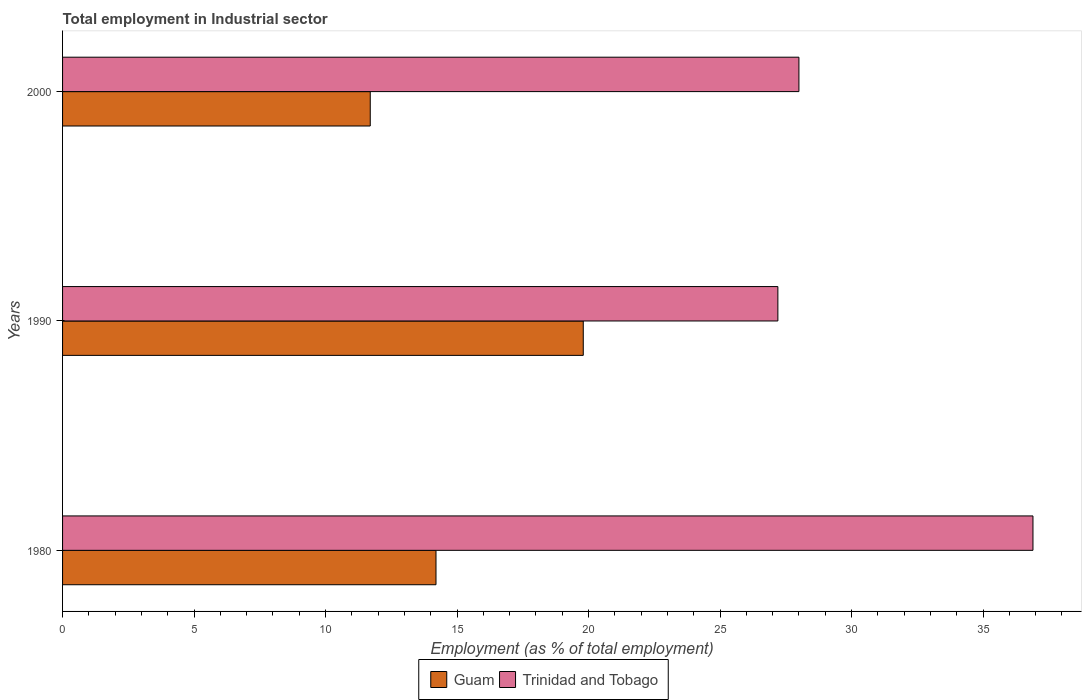How many different coloured bars are there?
Keep it short and to the point. 2. Are the number of bars on each tick of the Y-axis equal?
Offer a terse response. Yes. How many bars are there on the 3rd tick from the bottom?
Keep it short and to the point. 2. What is the label of the 2nd group of bars from the top?
Provide a short and direct response. 1990. In how many cases, is the number of bars for a given year not equal to the number of legend labels?
Make the answer very short. 0. What is the employment in industrial sector in Guam in 2000?
Provide a succinct answer. 11.7. Across all years, what is the maximum employment in industrial sector in Guam?
Give a very brief answer. 19.8. Across all years, what is the minimum employment in industrial sector in Trinidad and Tobago?
Provide a succinct answer. 27.2. In which year was the employment in industrial sector in Trinidad and Tobago minimum?
Offer a terse response. 1990. What is the total employment in industrial sector in Trinidad and Tobago in the graph?
Offer a terse response. 92.1. What is the difference between the employment in industrial sector in Guam in 1990 and the employment in industrial sector in Trinidad and Tobago in 1980?
Give a very brief answer. -17.1. What is the average employment in industrial sector in Guam per year?
Your response must be concise. 15.23. In the year 1990, what is the difference between the employment in industrial sector in Trinidad and Tobago and employment in industrial sector in Guam?
Your answer should be very brief. 7.4. What is the ratio of the employment in industrial sector in Trinidad and Tobago in 1990 to that in 2000?
Your answer should be very brief. 0.97. Is the employment in industrial sector in Trinidad and Tobago in 1990 less than that in 2000?
Ensure brevity in your answer.  Yes. What is the difference between the highest and the second highest employment in industrial sector in Guam?
Your answer should be compact. 5.6. What is the difference between the highest and the lowest employment in industrial sector in Trinidad and Tobago?
Provide a succinct answer. 9.7. What does the 2nd bar from the top in 2000 represents?
Make the answer very short. Guam. What does the 1st bar from the bottom in 2000 represents?
Your response must be concise. Guam. What is the difference between two consecutive major ticks on the X-axis?
Keep it short and to the point. 5. Are the values on the major ticks of X-axis written in scientific E-notation?
Make the answer very short. No. How many legend labels are there?
Give a very brief answer. 2. What is the title of the graph?
Offer a terse response. Total employment in Industrial sector. Does "Norway" appear as one of the legend labels in the graph?
Ensure brevity in your answer.  No. What is the label or title of the X-axis?
Provide a short and direct response. Employment (as % of total employment). What is the Employment (as % of total employment) in Guam in 1980?
Your response must be concise. 14.2. What is the Employment (as % of total employment) in Trinidad and Tobago in 1980?
Your answer should be compact. 36.9. What is the Employment (as % of total employment) of Guam in 1990?
Give a very brief answer. 19.8. What is the Employment (as % of total employment) in Trinidad and Tobago in 1990?
Provide a succinct answer. 27.2. What is the Employment (as % of total employment) of Guam in 2000?
Your response must be concise. 11.7. What is the Employment (as % of total employment) in Trinidad and Tobago in 2000?
Offer a very short reply. 28. Across all years, what is the maximum Employment (as % of total employment) in Guam?
Offer a terse response. 19.8. Across all years, what is the maximum Employment (as % of total employment) of Trinidad and Tobago?
Ensure brevity in your answer.  36.9. Across all years, what is the minimum Employment (as % of total employment) in Guam?
Ensure brevity in your answer.  11.7. Across all years, what is the minimum Employment (as % of total employment) in Trinidad and Tobago?
Ensure brevity in your answer.  27.2. What is the total Employment (as % of total employment) in Guam in the graph?
Your response must be concise. 45.7. What is the total Employment (as % of total employment) in Trinidad and Tobago in the graph?
Your response must be concise. 92.1. What is the difference between the Employment (as % of total employment) in Guam in 1980 and that in 1990?
Offer a terse response. -5.6. What is the difference between the Employment (as % of total employment) of Guam in 1980 and that in 2000?
Your answer should be compact. 2.5. What is the difference between the Employment (as % of total employment) in Trinidad and Tobago in 1980 and that in 2000?
Offer a terse response. 8.9. What is the difference between the Employment (as % of total employment) of Guam in 1990 and that in 2000?
Provide a short and direct response. 8.1. What is the average Employment (as % of total employment) of Guam per year?
Your response must be concise. 15.23. What is the average Employment (as % of total employment) of Trinidad and Tobago per year?
Provide a succinct answer. 30.7. In the year 1980, what is the difference between the Employment (as % of total employment) in Guam and Employment (as % of total employment) in Trinidad and Tobago?
Make the answer very short. -22.7. In the year 1990, what is the difference between the Employment (as % of total employment) in Guam and Employment (as % of total employment) in Trinidad and Tobago?
Ensure brevity in your answer.  -7.4. In the year 2000, what is the difference between the Employment (as % of total employment) of Guam and Employment (as % of total employment) of Trinidad and Tobago?
Ensure brevity in your answer.  -16.3. What is the ratio of the Employment (as % of total employment) of Guam in 1980 to that in 1990?
Your response must be concise. 0.72. What is the ratio of the Employment (as % of total employment) of Trinidad and Tobago in 1980 to that in 1990?
Your answer should be compact. 1.36. What is the ratio of the Employment (as % of total employment) of Guam in 1980 to that in 2000?
Your answer should be very brief. 1.21. What is the ratio of the Employment (as % of total employment) of Trinidad and Tobago in 1980 to that in 2000?
Your response must be concise. 1.32. What is the ratio of the Employment (as % of total employment) of Guam in 1990 to that in 2000?
Your answer should be very brief. 1.69. What is the ratio of the Employment (as % of total employment) in Trinidad and Tobago in 1990 to that in 2000?
Your response must be concise. 0.97. What is the difference between the highest and the second highest Employment (as % of total employment) of Guam?
Your response must be concise. 5.6. What is the difference between the highest and the lowest Employment (as % of total employment) in Guam?
Give a very brief answer. 8.1. What is the difference between the highest and the lowest Employment (as % of total employment) in Trinidad and Tobago?
Provide a succinct answer. 9.7. 